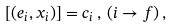<formula> <loc_0><loc_0><loc_500><loc_500>[ ( e _ { i } , x _ { i } ) ] = c _ { i } \, , \, ( i \rightarrow f ) \, ,</formula> 